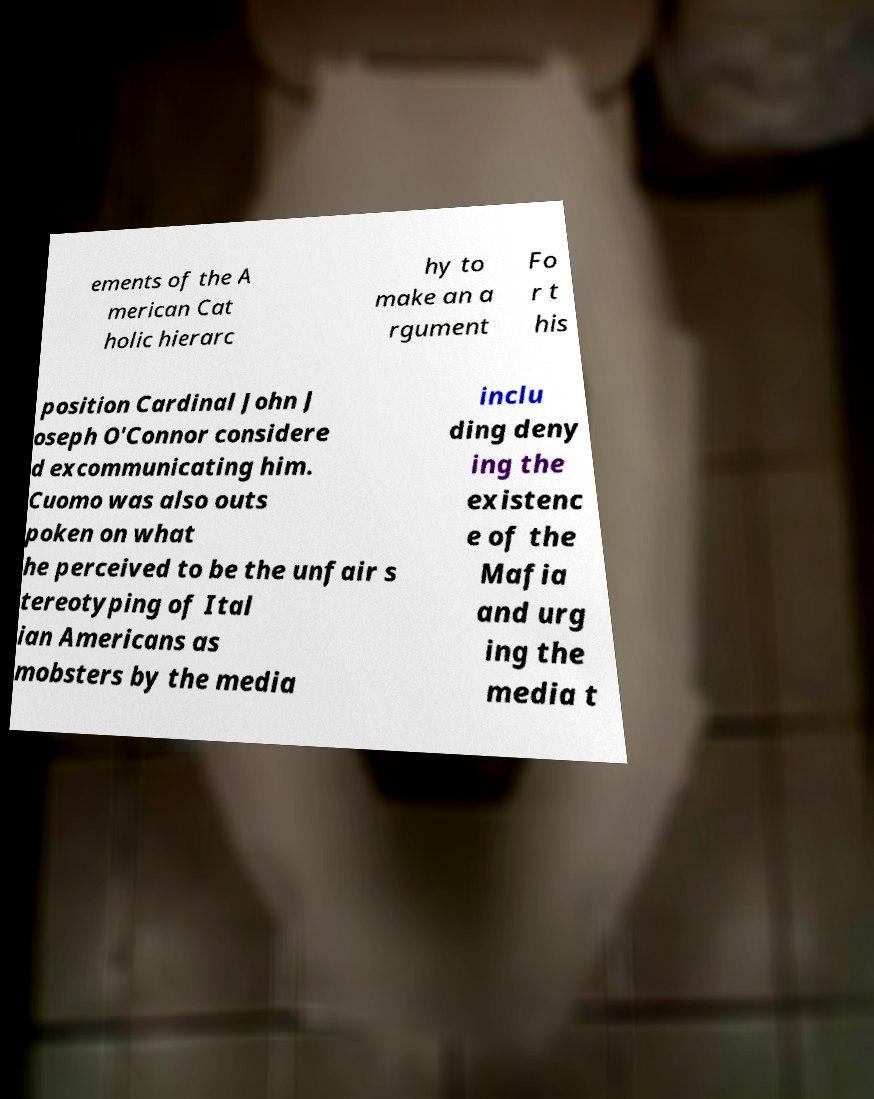There's text embedded in this image that I need extracted. Can you transcribe it verbatim? ements of the A merican Cat holic hierarc hy to make an a rgument Fo r t his position Cardinal John J oseph O'Connor considere d excommunicating him. Cuomo was also outs poken on what he perceived to be the unfair s tereotyping of Ital ian Americans as mobsters by the media inclu ding deny ing the existenc e of the Mafia and urg ing the media t 